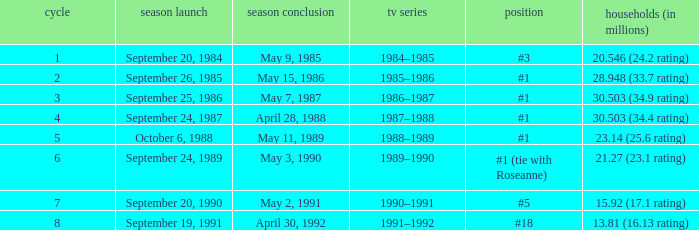Which TV season has Households (in millions) of 30.503 (34.9 rating)? 1986–1987. 